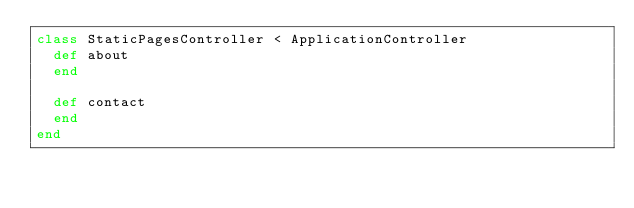Convert code to text. <code><loc_0><loc_0><loc_500><loc_500><_Ruby_>class StaticPagesController < ApplicationController
  def about
  end

  def contact
  end
end
</code> 